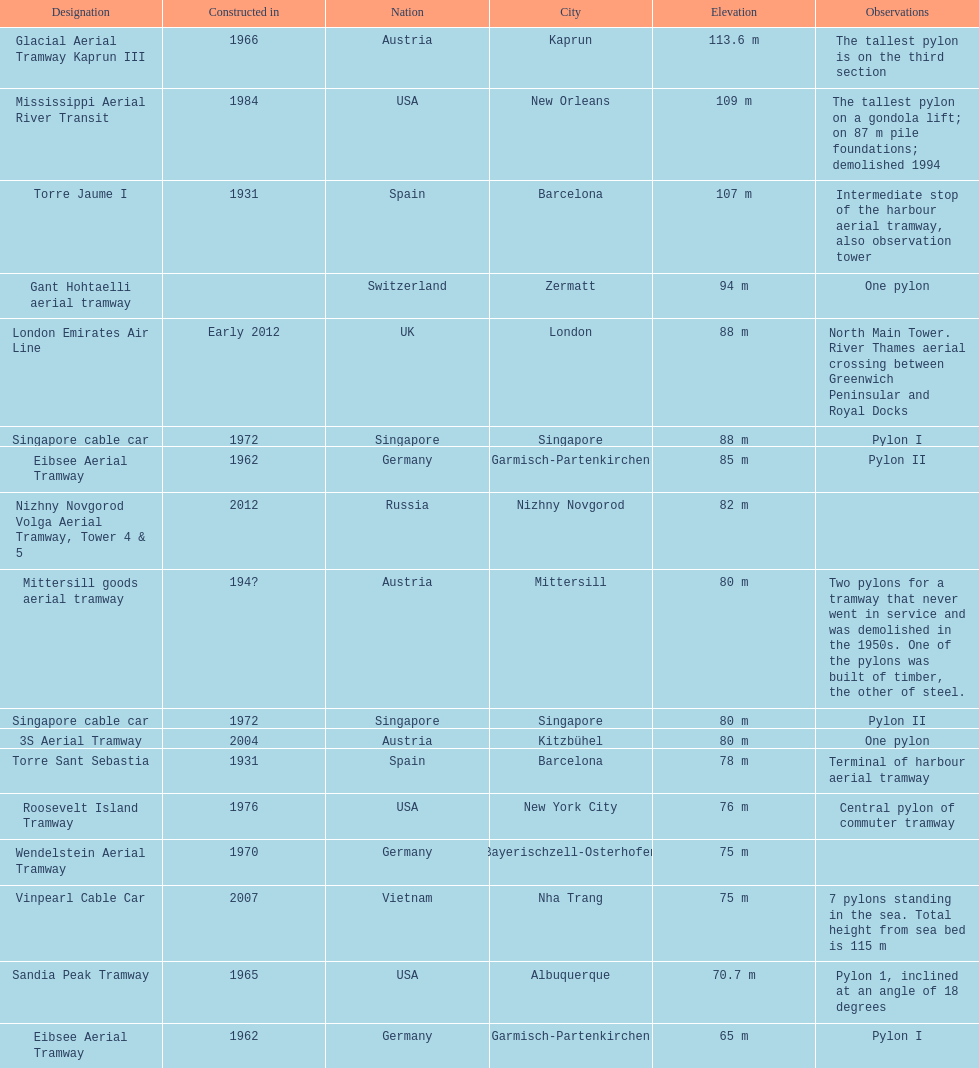How many pylons are at least 80 meters tall? 11. 